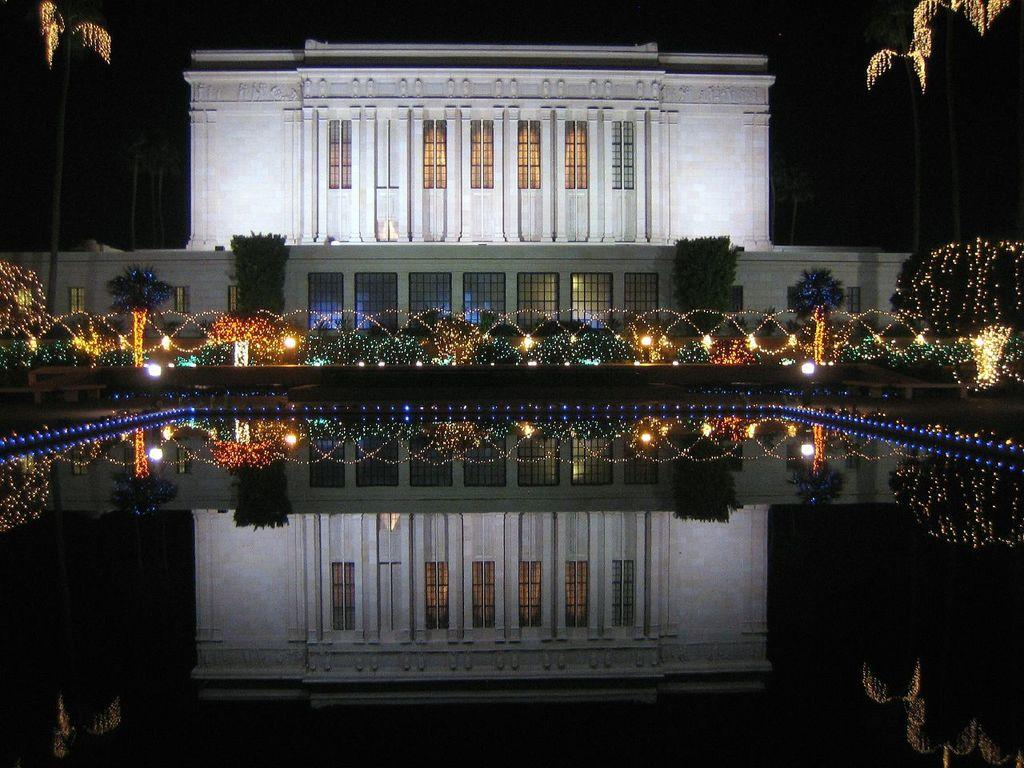What type of structure can be seen in the background of the image? There is a building in the background of the image. What is visible at the bottom of the image? There is water visible at the bottom of the image. What can be used to illuminate the scene in the image? There are lights present in the image. What type of natural elements are visible in the background of the image? There are plants in the background of the image. What type of jeans is the idea wearing in the image? There is no person wearing jeans or any idea present in the image; it features a building, water, lights, and plants. 